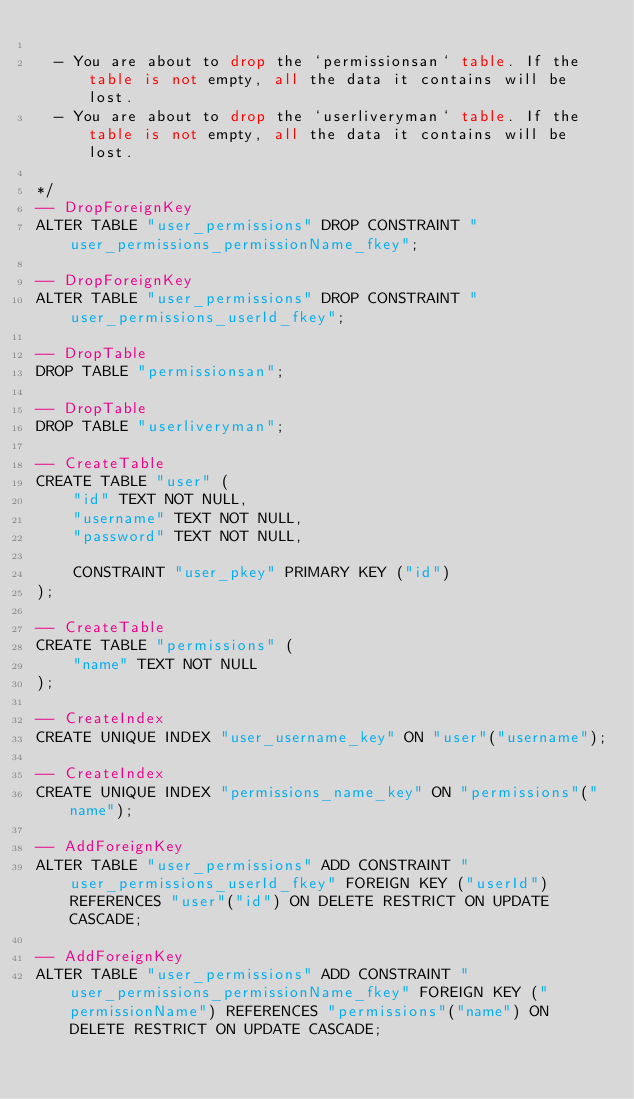Convert code to text. <code><loc_0><loc_0><loc_500><loc_500><_SQL_>
  - You are about to drop the `permissionsan` table. If the table is not empty, all the data it contains will be lost.
  - You are about to drop the `userliveryman` table. If the table is not empty, all the data it contains will be lost.

*/
-- DropForeignKey
ALTER TABLE "user_permissions" DROP CONSTRAINT "user_permissions_permissionName_fkey";

-- DropForeignKey
ALTER TABLE "user_permissions" DROP CONSTRAINT "user_permissions_userId_fkey";

-- DropTable
DROP TABLE "permissionsan";

-- DropTable
DROP TABLE "userliveryman";

-- CreateTable
CREATE TABLE "user" (
    "id" TEXT NOT NULL,
    "username" TEXT NOT NULL,
    "password" TEXT NOT NULL,

    CONSTRAINT "user_pkey" PRIMARY KEY ("id")
);

-- CreateTable
CREATE TABLE "permissions" (
    "name" TEXT NOT NULL
);

-- CreateIndex
CREATE UNIQUE INDEX "user_username_key" ON "user"("username");

-- CreateIndex
CREATE UNIQUE INDEX "permissions_name_key" ON "permissions"("name");

-- AddForeignKey
ALTER TABLE "user_permissions" ADD CONSTRAINT "user_permissions_userId_fkey" FOREIGN KEY ("userId") REFERENCES "user"("id") ON DELETE RESTRICT ON UPDATE CASCADE;

-- AddForeignKey
ALTER TABLE "user_permissions" ADD CONSTRAINT "user_permissions_permissionName_fkey" FOREIGN KEY ("permissionName") REFERENCES "permissions"("name") ON DELETE RESTRICT ON UPDATE CASCADE;
</code> 